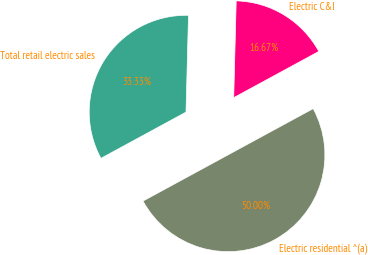Convert chart. <chart><loc_0><loc_0><loc_500><loc_500><pie_chart><fcel>Electric residential ^(a)<fcel>Electric C&I<fcel>Total retail electric sales<nl><fcel>50.0%<fcel>16.67%<fcel>33.33%<nl></chart> 